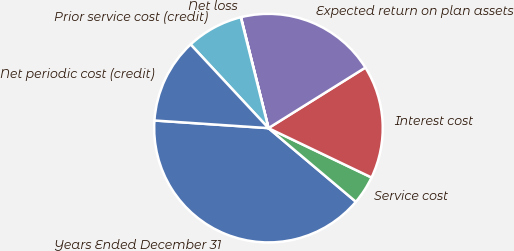<chart> <loc_0><loc_0><loc_500><loc_500><pie_chart><fcel>Years Ended December 31<fcel>Service cost<fcel>Interest cost<fcel>Expected return on plan assets<fcel>Net loss<fcel>Prior service cost (credit)<fcel>Net periodic cost (credit)<nl><fcel>39.93%<fcel>4.03%<fcel>16.0%<fcel>19.98%<fcel>0.04%<fcel>8.02%<fcel>12.01%<nl></chart> 